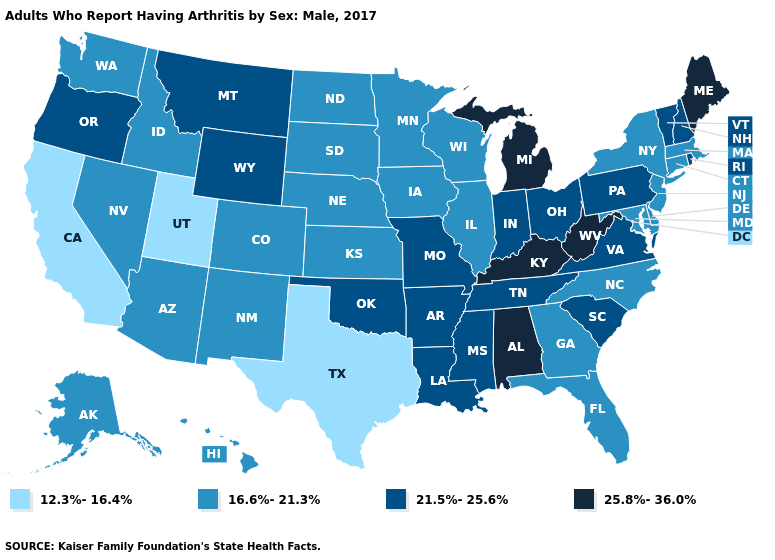What is the value of Nevada?
Keep it brief. 16.6%-21.3%. Does California have a higher value than Vermont?
Concise answer only. No. Among the states that border Mississippi , does Alabama have the highest value?
Write a very short answer. Yes. What is the value of Nebraska?
Quick response, please. 16.6%-21.3%. What is the value of Ohio?
Quick response, please. 21.5%-25.6%. Does Colorado have a higher value than Texas?
Give a very brief answer. Yes. Name the states that have a value in the range 12.3%-16.4%?
Quick response, please. California, Texas, Utah. Name the states that have a value in the range 25.8%-36.0%?
Concise answer only. Alabama, Kentucky, Maine, Michigan, West Virginia. Which states have the lowest value in the USA?
Quick response, please. California, Texas, Utah. Does Nebraska have a higher value than Missouri?
Answer briefly. No. Among the states that border North Dakota , does Minnesota have the lowest value?
Keep it brief. Yes. What is the lowest value in states that border Kentucky?
Write a very short answer. 16.6%-21.3%. What is the highest value in states that border Tennessee?
Short answer required. 25.8%-36.0%. What is the lowest value in the MidWest?
Answer briefly. 16.6%-21.3%. Does the first symbol in the legend represent the smallest category?
Concise answer only. Yes. 